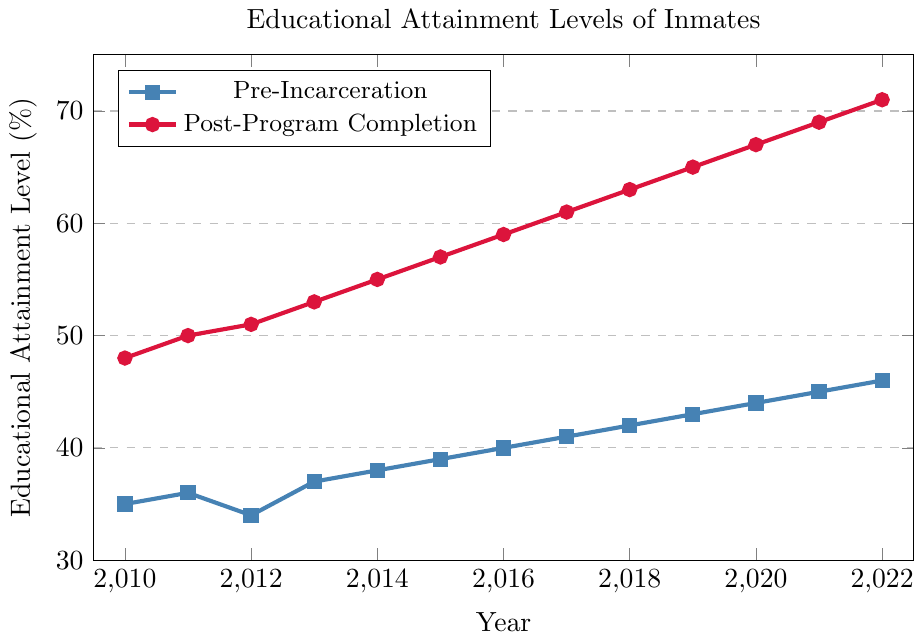What's the highest educational attainment level reached after the program completion? Look at the Post-Program Completion data series and identify the highest value, which is 71% in the year 2022.
Answer: 71% What's the lowest educational attainment level before incarceration? Check the Pre-Incarceration data series and find the smallest value, which is 34% in the year 2012.
Answer: 34% What is the average educational attainment level before incarceration from 2010 to 2022? Sum the Pre-Incarceration values (35+36+34+37+38+39+40+41+42+43+44+45+46) which equals 520. Divide by the number of years (13) to get the average: 520/13 = 40%.
Answer: 40% How much did the educational attainment level increase from pre-incarceration to post-program completion in 2015? Subtract the Pre-Incarceration value for 2015 (39) from the Post-Program Completion value for 2015 (57). The increase is 57 - 39 = 18%.
Answer: 18% In which year was the difference between pre-incarceration and post-program completion attainment levels the smallest? Calculate the difference for each year and compare. The differences are 2010: 13, 2011: 14, 2012: 17, 2013: 16, 2014: 17, 2015: 18, 2016: 19, 2017: 20, 2018: 21, 2019: 22, 2020: 23, 2021: 24, 2022: 25. The smallest difference is in 2010.
Answer: 2010 Which color line represents the post-program completion data? There are two lines in the chart: one is blue and the other is red. The legend indicates that the red line represents Post-Program Completion data.
Answer: Red Which year had an educational attainment level before incarceration equal to 40%? Check the Pre-Incarceration line and find the year where the value is 40%. This occurs in 2016.
Answer: 2016 By how much did the educational attainment level at post-program completion increase from 2013 to 2017? Subtract the Post-Program Completion value in 2013 (53) from the value in 2017 (61). The increase is 61 - 53 = 8%.
Answer: 8% What was the educational attainment level before incarceration in 2010, and how does it compare to the value in 2022? Locate the Pre-Incarceration values for 2010 (35%) and 2022 (46%). The value in 2022 is higher, with a difference of 46 - 35 = 11%.
Answer: Pre-incarceration in 2010: 35%, 2022 is higher by 11% How does the overall trend of educational attainment levels from pre-incarceration to post-program completion appear over the years? Observe the trend over the years from 2010 to 2022. Both lines show an increasing trend, with post-program completion levels consistently higher than pre-incarceration levels.
Answer: Increasing trend 